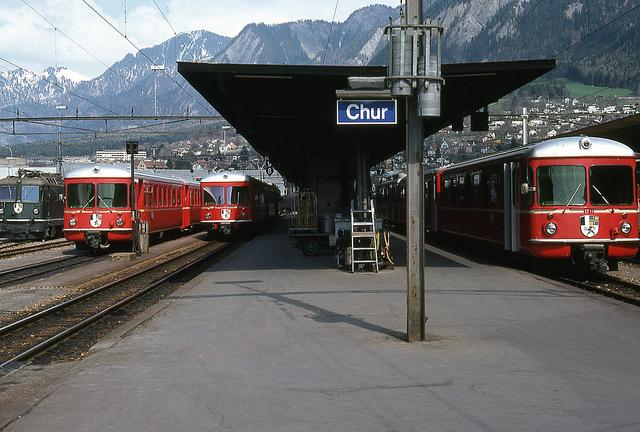What mountains are these? Please explain your reasoning. alps. The chur train station is located in switzerland so the best option is the mountains located in that country. 